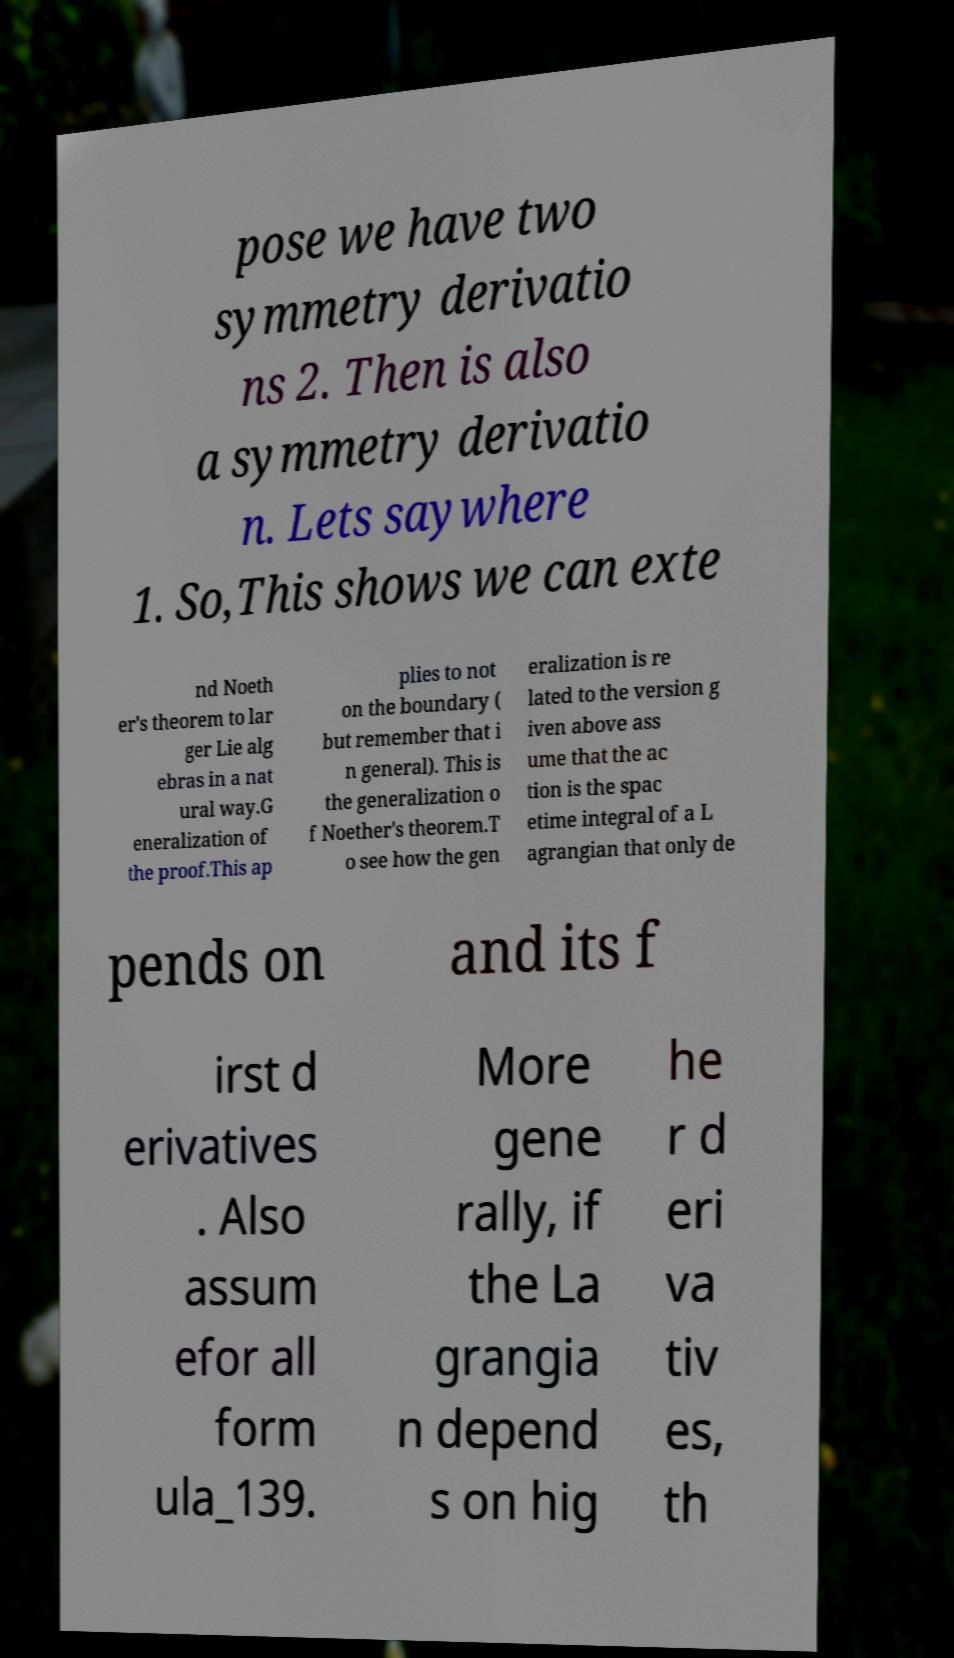There's text embedded in this image that I need extracted. Can you transcribe it verbatim? pose we have two symmetry derivatio ns 2. Then is also a symmetry derivatio n. Lets saywhere 1. So,This shows we can exte nd Noeth er's theorem to lar ger Lie alg ebras in a nat ural way.G eneralization of the proof.This ap plies to not on the boundary ( but remember that i n general). This is the generalization o f Noether's theorem.T o see how the gen eralization is re lated to the version g iven above ass ume that the ac tion is the spac etime integral of a L agrangian that only de pends on and its f irst d erivatives . Also assum efor all form ula_139. More gene rally, if the La grangia n depend s on hig he r d eri va tiv es, th 